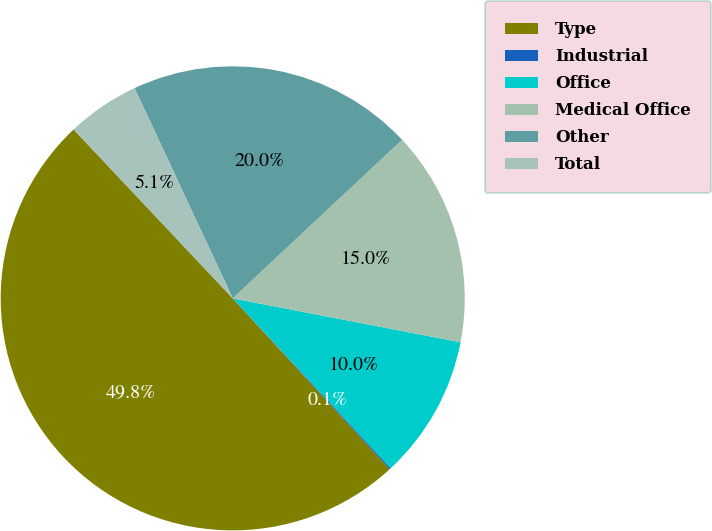Convert chart to OTSL. <chart><loc_0><loc_0><loc_500><loc_500><pie_chart><fcel>Type<fcel>Industrial<fcel>Office<fcel>Medical Office<fcel>Other<fcel>Total<nl><fcel>49.81%<fcel>0.1%<fcel>10.04%<fcel>15.01%<fcel>19.98%<fcel>5.07%<nl></chart> 